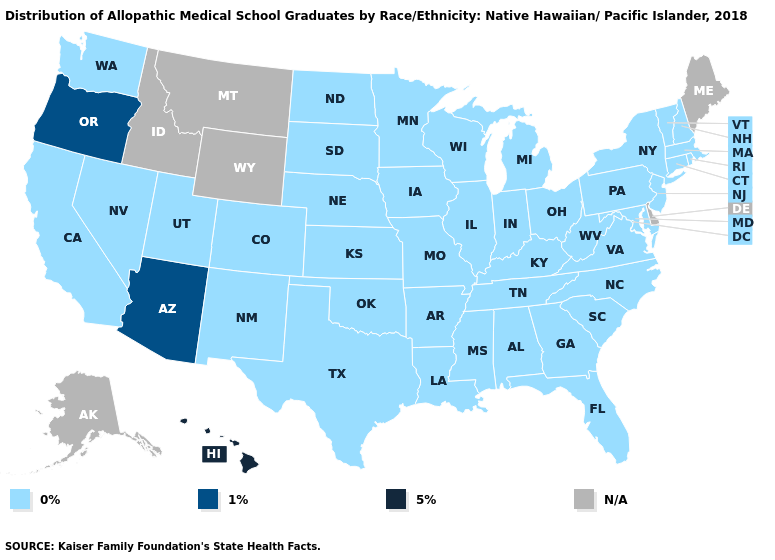What is the lowest value in the USA?
Answer briefly. 0%. Name the states that have a value in the range 0%?
Keep it brief. Alabama, Arkansas, California, Colorado, Connecticut, Florida, Georgia, Illinois, Indiana, Iowa, Kansas, Kentucky, Louisiana, Maryland, Massachusetts, Michigan, Minnesota, Mississippi, Missouri, Nebraska, Nevada, New Hampshire, New Jersey, New Mexico, New York, North Carolina, North Dakota, Ohio, Oklahoma, Pennsylvania, Rhode Island, South Carolina, South Dakota, Tennessee, Texas, Utah, Vermont, Virginia, Washington, West Virginia, Wisconsin. What is the value of Maine?
Answer briefly. N/A. Does the first symbol in the legend represent the smallest category?
Write a very short answer. Yes. What is the lowest value in the USA?
Give a very brief answer. 0%. Which states have the highest value in the USA?
Answer briefly. Hawaii. What is the lowest value in states that border Idaho?
Be succinct. 0%. Among the states that border Montana , which have the highest value?
Give a very brief answer. North Dakota, South Dakota. What is the highest value in the MidWest ?
Keep it brief. 0%. What is the value of Minnesota?
Keep it brief. 0%. What is the value of Mississippi?
Quick response, please. 0%. What is the highest value in states that border New Mexico?
Concise answer only. 1%. 